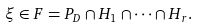<formula> <loc_0><loc_0><loc_500><loc_500>\xi \in F = P _ { D } \cap H _ { 1 } \cap \dots \cap H _ { r } .</formula> 